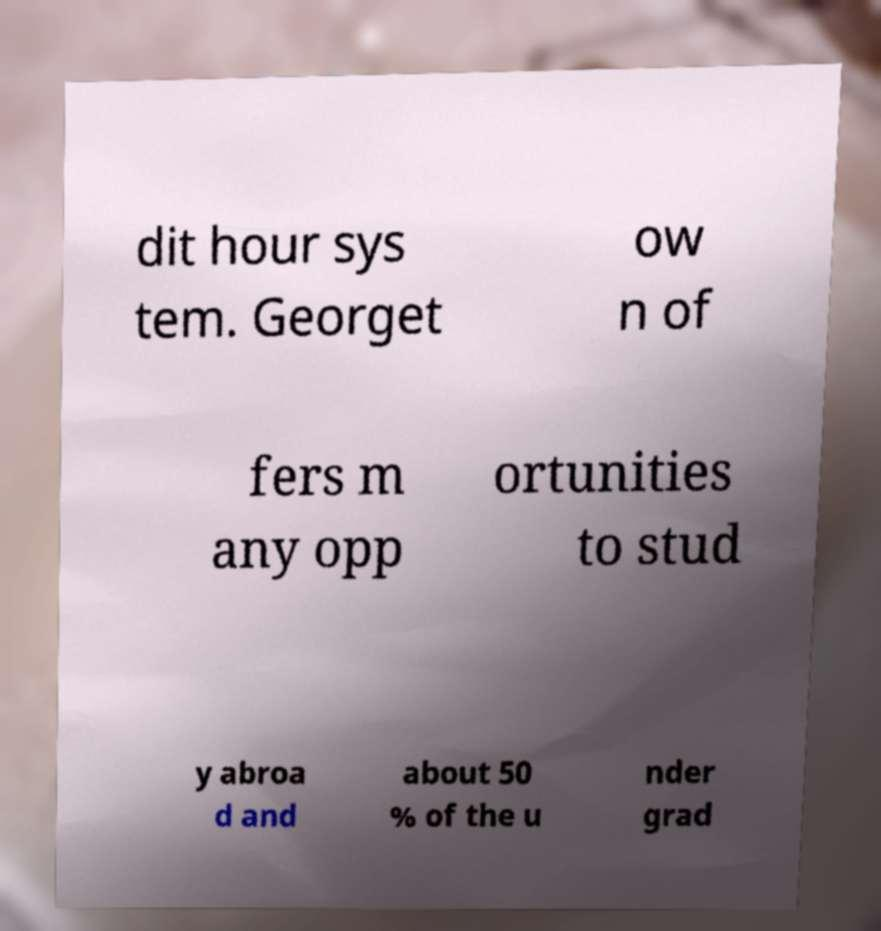Can you read and provide the text displayed in the image?This photo seems to have some interesting text. Can you extract and type it out for me? dit hour sys tem. Georget ow n of fers m any opp ortunities to stud y abroa d and about 50 % of the u nder grad 